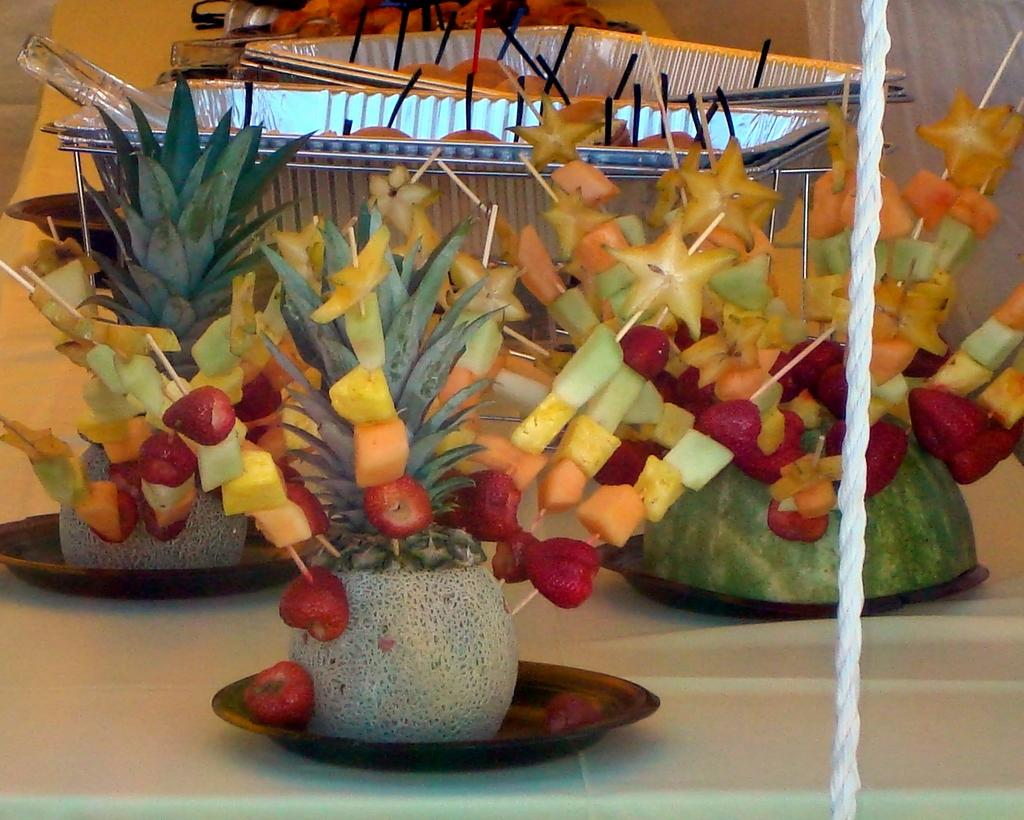What type of food items are present in the image? There is a group of fruits in the image. How are the fruits arranged or organized? The fruits are placed in different containers. What can be seen on the table in the image? There are plates on a table in the image. What object is located on the right side of the image? There is a rope on the right side of the image. What type of yak can be seen grazing on the soup in the image? There is no yak or soup present in the image; it features a group of fruits in different containers and plates on a table. 